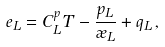Convert formula to latex. <formula><loc_0><loc_0><loc_500><loc_500>e _ { L } = C ^ { p } _ { L } T - \frac { p _ { L } } { \rho _ { L } } + q _ { L } \, ,</formula> 